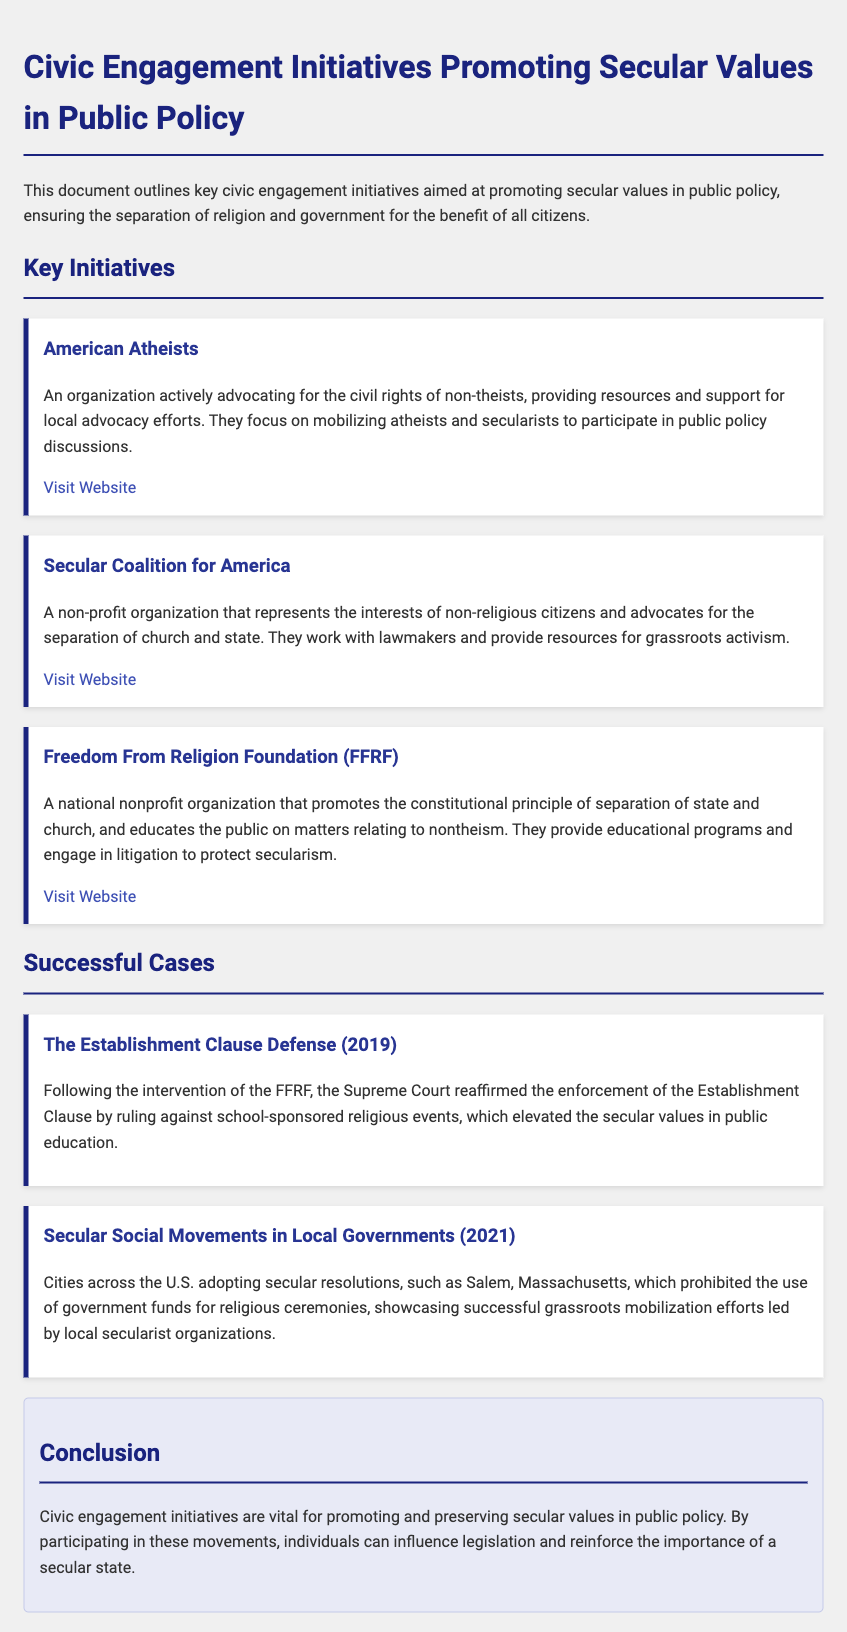What organization advocates for the civil rights of non-theists? The document states that American Atheists is an organization actively advocating for the civil rights of non-theists.
Answer: American Atheists What is the primary focus of the Secular Coalition for America? According to the document, the primary focus of the Secular Coalition for America is the separation of church and state.
Answer: Separation of church and state In what year did the Supreme Court reaffirm the enforcement of the Establishment Clause? The document mentions that this reaffirmation occurred in 2019.
Answer: 2019 Which Massachusetts city prohibited the use of government funds for religious ceremonies? The document specifies that Salem, Massachusetts, is the city that prohibited the use of government funds for religious ceremonies.
Answer: Salem What type of engagement initiatives does the document promote? The document outlines initiatives aimed at promoting secular values in public policy.
Answer: Secular values in public policy How does the Freedom From Religion Foundation contribute to public education? The document mentions that they engage in litigation to protect secularism, which affects public education.
Answer: Litigation to protect secularism What essential principle does the Freedom From Religion Foundation promote? The foundation promotes the constitutional principle of separation of state and church.
Answer: Separation of state and church What activity do civic engagement initiatives aim to influence? The document indicates that these initiatives aim to influence legislation.
Answer: Legislation 